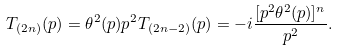<formula> <loc_0><loc_0><loc_500><loc_500>T _ { ( 2 n ) } ( p ) = \theta ^ { 2 } ( p ) p ^ { 2 } T _ { ( 2 n - 2 ) } ( p ) = - i \frac { [ p ^ { 2 } \theta ^ { 2 } ( p ) ] ^ { n } } { p ^ { 2 } } .</formula> 